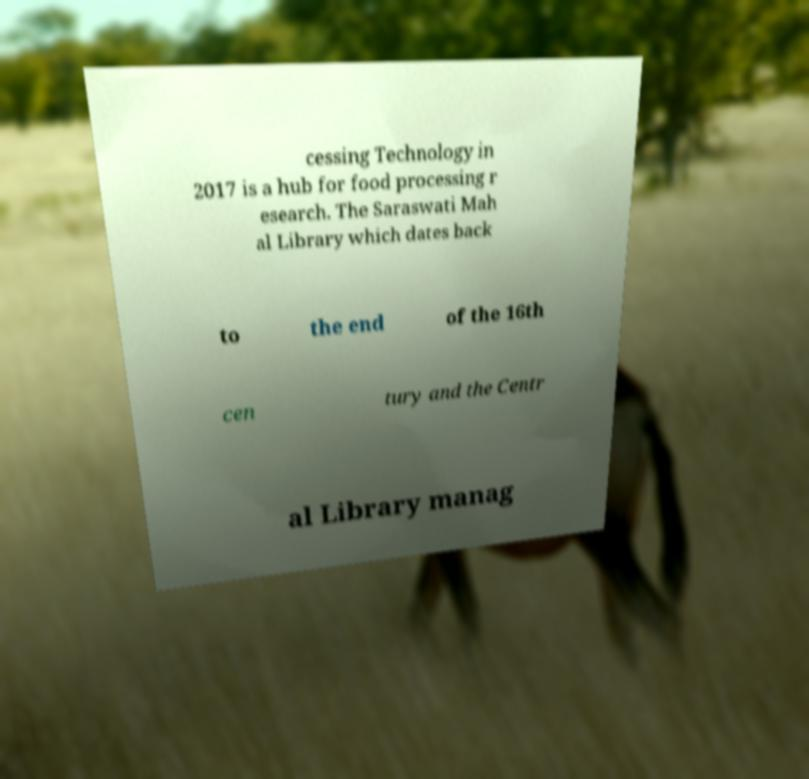Could you assist in decoding the text presented in this image and type it out clearly? cessing Technology in 2017 is a hub for food processing r esearch. The Saraswati Mah al Library which dates back to the end of the 16th cen tury and the Centr al Library manag 